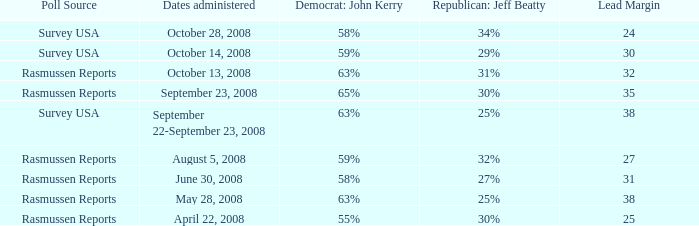What is the maximum lead margin on august 5, 2008? 27.0. 